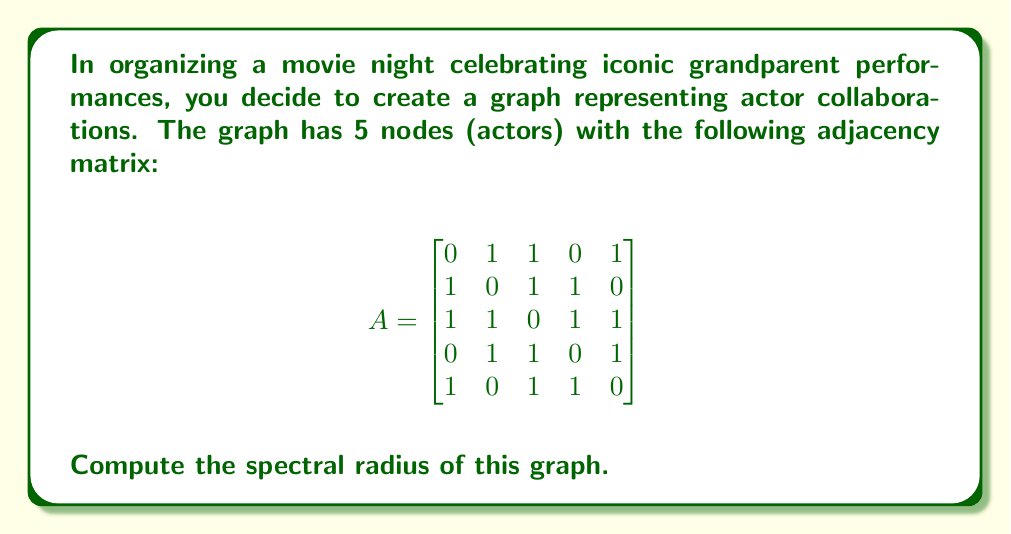Could you help me with this problem? To find the spectral radius of the graph, we need to follow these steps:

1) The spectral radius is the largest absolute value of the eigenvalues of the adjacency matrix.

2) To find the eigenvalues, we need to solve the characteristic equation:
   $\det(A - \lambda I) = 0$

3) Expanding this determinant:
   $$\begin{vmatrix}
   -\lambda & 1 & 1 & 0 & 1 \\
   1 & -\lambda & 1 & 1 & 0 \\
   1 & 1 & -\lambda & 1 & 1 \\
   0 & 1 & 1 & -\lambda & 1 \\
   1 & 0 & 1 & 1 & -\lambda
   \end{vmatrix} = 0$$

4) This expands to the characteristic polynomial:
   $\lambda^5 - 10\lambda^3 - 8\lambda^2 + 5\lambda + 4 = 0$

5) The roots of this polynomial are the eigenvalues. While it's difficult to solve this by hand, we can use numerical methods or computer algebra systems to find the roots.

6) The eigenvalues are approximately:
   $\lambda_1 \approx 2.7720$
   $\lambda_2 \approx -1.7720$
   $\lambda_3 \approx 1.0000$
   $\lambda_4 \approx -1.0000$
   $\lambda_5 \approx 0.0000$

7) The spectral radius is the largest absolute value among these eigenvalues, which is $|\lambda_1| \approx 2.7720$.
Answer: $2.7720$ (rounded to 4 decimal places) 